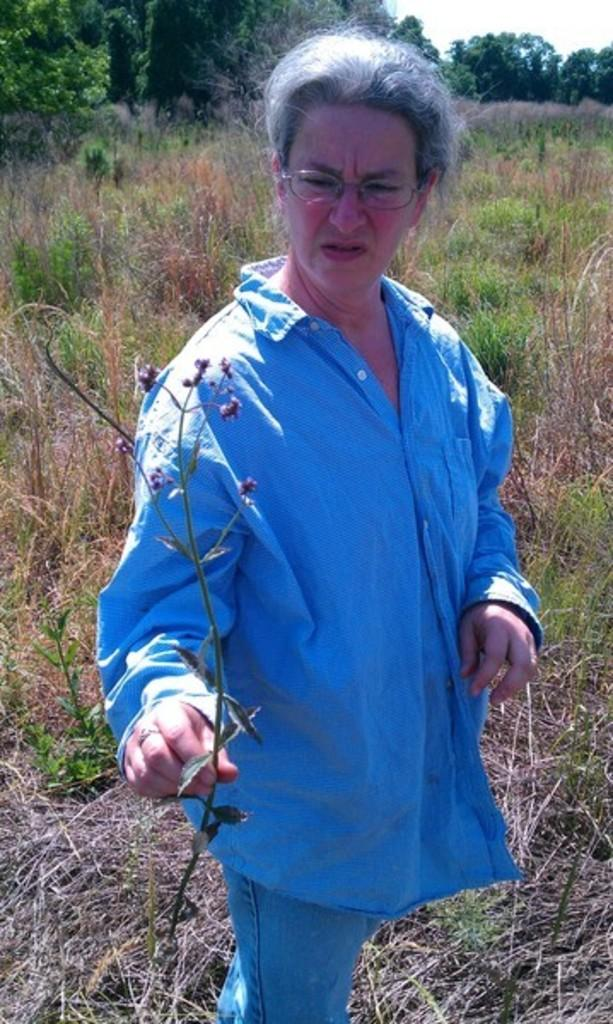Who is present in the image? There is a woman in the image. What is the woman holding in her hand? The woman is holding a stem in her hand. What can be seen in the background of the image? There is a lot of grass, plants, and trees in the background of the image. What type of coal can be seen in the image? There is no coal present in the image. What season is depicted in the image? The provided facts do not mention the season, so it cannot be determined from the image. 